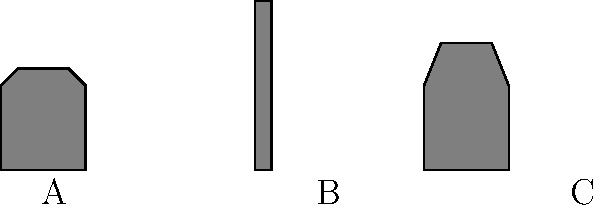Identify the Pakistani landmark represented by silhouette B in the image above. To identify the Pakistani landmark represented by silhouette B, let's analyze each silhouette:

1. Silhouette A: This shape represents a domed structure with minarets, characteristic of the Badshahi Mosque in Lahore.

2. Silhouette B: This is a tall, slender tower-like structure. It represents the Minar-e-Pakistan (Pakistan Monument) in Lahore, which is a national monument built to commemorate the Lahore Resolution.

3. Silhouette C: This shape depicts a modern mosque design with a triangular roof, representing the Faisal Mosque in Islamabad.

The question asks specifically about silhouette B, which is the tall, tower-like structure. This distinctive shape is unmistakably the Minar-e-Pakistan, a significant landmark in Lahore and an important symbol of Pakistan's independence movement.
Answer: Minar-e-Pakistan 